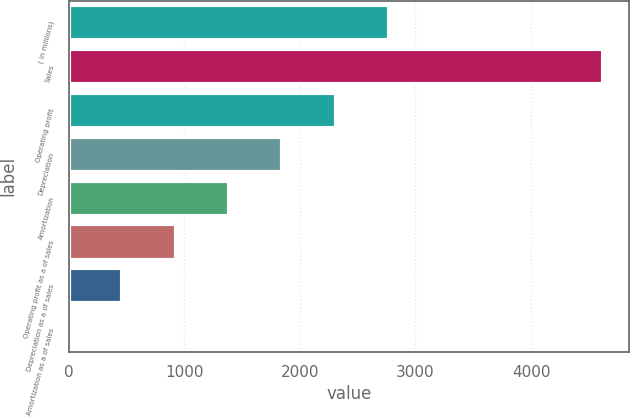Convert chart to OTSL. <chart><loc_0><loc_0><loc_500><loc_500><bar_chart><fcel>( in millions)<fcel>Sales<fcel>Operating profit<fcel>Depreciation<fcel>Amortization<fcel>Operating profit as a of sales<fcel>Depreciation as a of sales<fcel>Amortization as a of sales<nl><fcel>2772.32<fcel>4618.8<fcel>2310.7<fcel>1849.08<fcel>1387.46<fcel>925.84<fcel>464.22<fcel>2.6<nl></chart> 